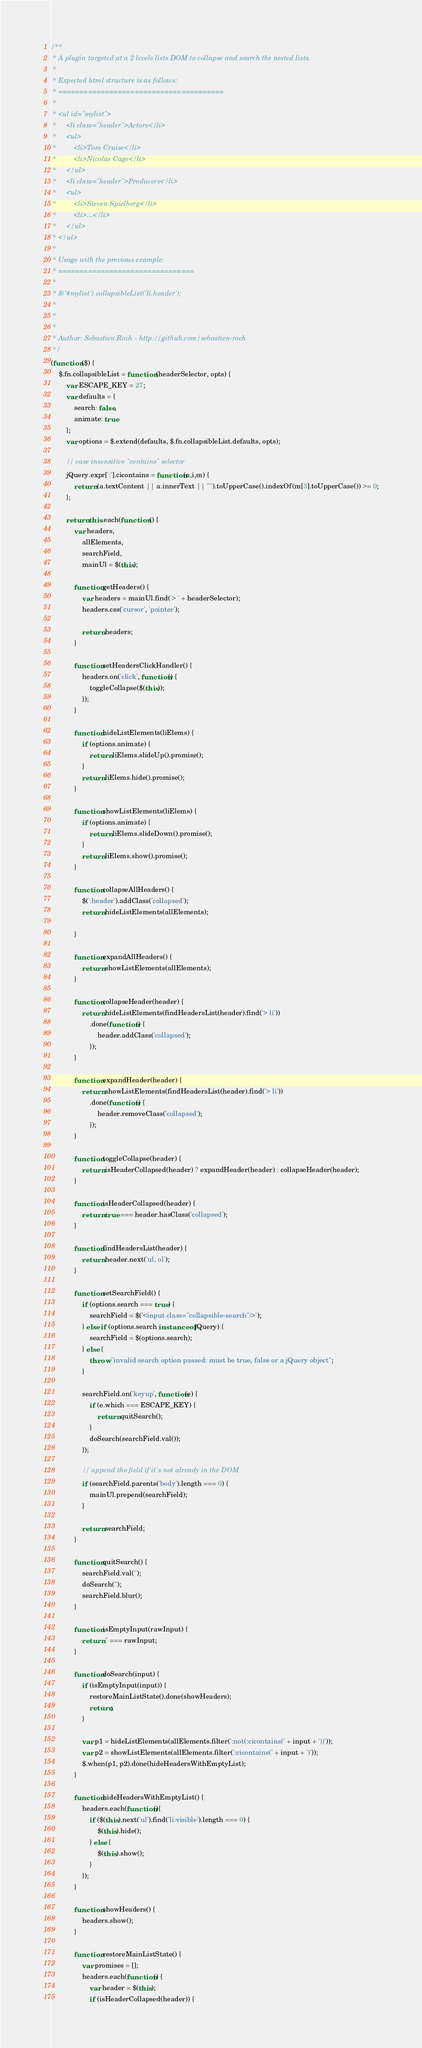<code> <loc_0><loc_0><loc_500><loc_500><_JavaScript_>/**
 * A plugin targeted at a 2 levels lists DOM to collapse and search the nested lists.
 *
 * Expected html structure is as follows:
 * =======================================
 *
 * <ul id="mylist">
 *     <li class="header">Actors</li>
 *     <ul>
 *         <li>Tom Cruise</li>
 *         <li>Nicolas Cage</li>
 *     </ul>
 *     <li class="header">Producers</li>
 *     <ul>
 *         <li>Steven Spielberg</li>
 *         <li>...</li>
 *     </ul>
 * </ul>
 *
 * Usage with the previous example:
 * ================================
 *
 * $('#mylist').collapsibleList('li.header');
 *
 *
 *
 * Author: Sebastien Roch - http://github.com/sebastien-roch
 */
(function ($) {
    $.fn.collapsibleList = function (headerSelector, opts) {
        var ESCAPE_KEY = 27;
        var defaults = {
            search: false,
            animate: true
        };
        var options = $.extend(defaults, $.fn.collapsibleList.defaults, opts);

        // case insensitive "contains" selector
        jQuery.expr[':'].cicontains = function(a,i,m) {
            return (a.textContent || a.innerText || "").toUpperCase().indexOf(m[3].toUpperCase()) >= 0;
        };

        return this.each(function () {
            var headers,
                allElements,
                searchField,
                mainUl = $(this);

            function getHeaders() {
                var headers = mainUl.find('> ' + headerSelector);
                headers.css('cursor', 'pointer');

                return headers;
            }

            function setHeadersClickHandler() {
                headers.on('click', function() {
                    toggleCollapse($(this));
                });
            }

            function hideListElements(liElems) {
                if (options.animate) {
                    return liElems.slideUp().promise();
                }
                return liElems.hide().promise();
            }

            function showListElements(liElems) {
                if (options.animate) {
                    return liElems.slideDown().promise();
                }
                return liElems.show().promise();
            }

            function collapseAllHeaders() {
            	$('.header').addClass('collapsed');
                return hideListElements(allElements);
                
            }

            function expandAllHeaders() {
                return showListElements(allElements);
            }

            function collapseHeader(header) {
                return hideListElements(findHeadersList(header).find('> li'))
                    .done(function() {
                        header.addClass('collapsed');
                    });
            }

            function expandHeader(header) {
                return showListElements(findHeadersList(header).find('> li'))
                    .done(function() {
                        header.removeClass('collapsed');
                    });
            }

            function toggleCollapse(header) {
                return isHeaderCollapsed(header) ? expandHeader(header) : collapseHeader(header);
            }

            function isHeaderCollapsed(header) {
                return true === header.hasClass('collapsed');
            }

            function findHeadersList(header) {
                return header.next('ul, ol');
            }

            function setSearchField() {
                if (options.search === true) {
                    searchField = $('<input class="collapsible-search"/>');
                } else if (options.search instanceof jQuery) {
                    searchField = $(options.search);
                } else {
                    throw "invalid search option passed: must be true, false or a jQuery object";
                }

                searchField.on('keyup', function(e) {
                    if (e.which === ESCAPE_KEY) {
                        return quitSearch();
                    }
                    doSearch(searchField.val());
                });

                // append the field if it's not already in the DOM
                if (searchField.parents('body').length === 0) {
                    mainUl.prepend(searchField);
                }

                return searchField;
            }

            function quitSearch() {
                searchField.val('');
                doSearch('');
                searchField.blur();
            }

            function isEmptyInput(rawInput) {
                return '' === rawInput;
            }

            function doSearch(input) {
                if (isEmptyInput(input)) {
                    restoreMainListState().done(showHeaders);
                    return;
                }

                var p1 = hideListElements(allElements.filter(':not(:cicontains(' + input + '))'));
                var p2 = showListElements(allElements.filter(':cicontains(' + input + ')'));
                $.when(p1, p2).done(hideHeadersWithEmptyList);
            }

            function hideHeadersWithEmptyList() {
                headers.each(function(){
                    if ($(this).next('ul').find('li:visible').length === 0) {
                        $(this).hide();
                    } else {
                        $(this).show();
                    }
                });
            }

            function showHeaders() {
                headers.show();
            }

            function restoreMainListState() {
                var promises = [];
                headers.each(function() {
                    var header = $(this);
                    if (isHeaderCollapsed(header)) {</code> 